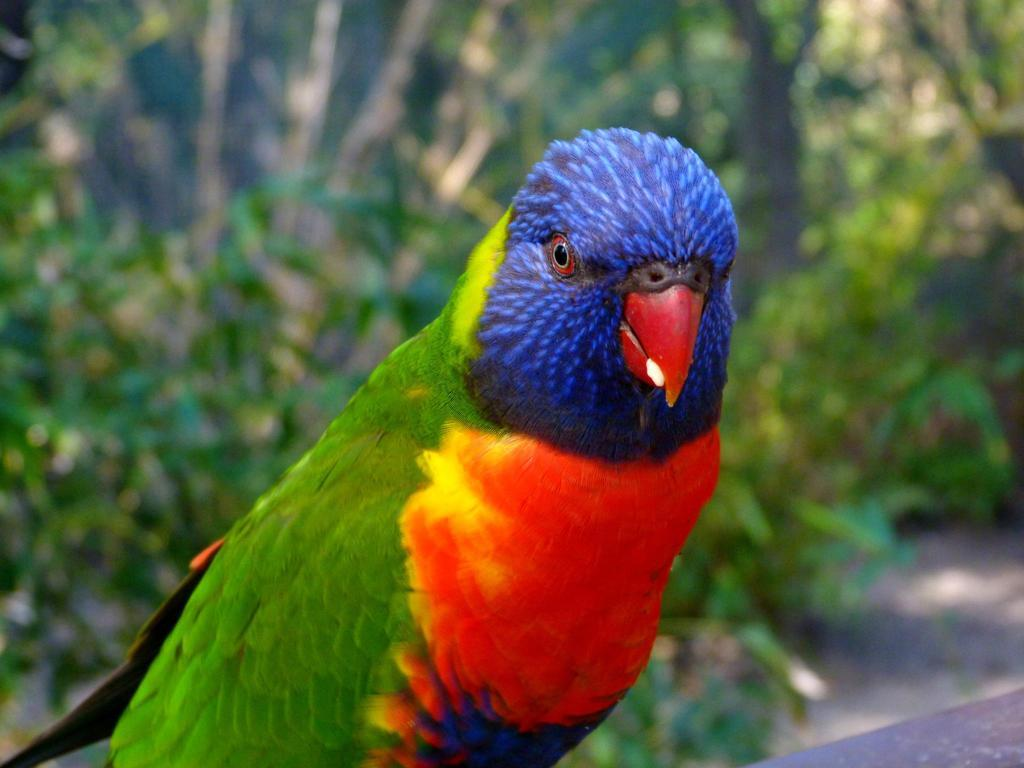What type of animal is in the image? There is a parrot in the image. Can you describe the background of the image? The background of the image is blurred. What type of authority figure can be seen in the image? There is no authority figure present in the image; it only features a parrot. What is the parrot standing on in the image? The provided facts do not mention the parrot standing on anything, so we cannot determine what it might be standing on. 